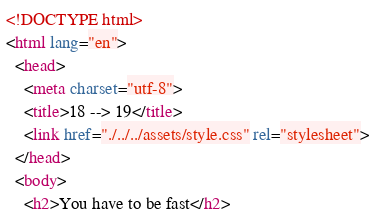Convert code to text. <code><loc_0><loc_0><loc_500><loc_500><_HTML_><!DOCTYPE html>
<html lang="en">
  <head>
    <meta charset="utf-8">
    <title>18 --> 19</title>
    <link href="./../../assets/style.css" rel="stylesheet">
  </head>
  <body>
    <h2>You have to be fast</h2></code> 